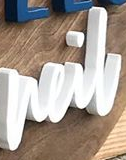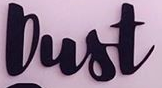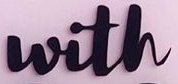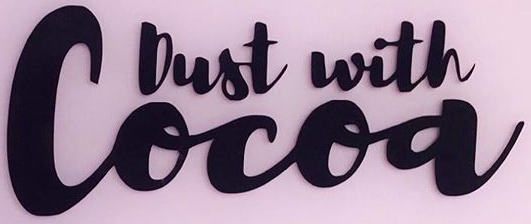Read the text from these images in sequence, separated by a semicolon. neil; Dust; with; Cocoa 